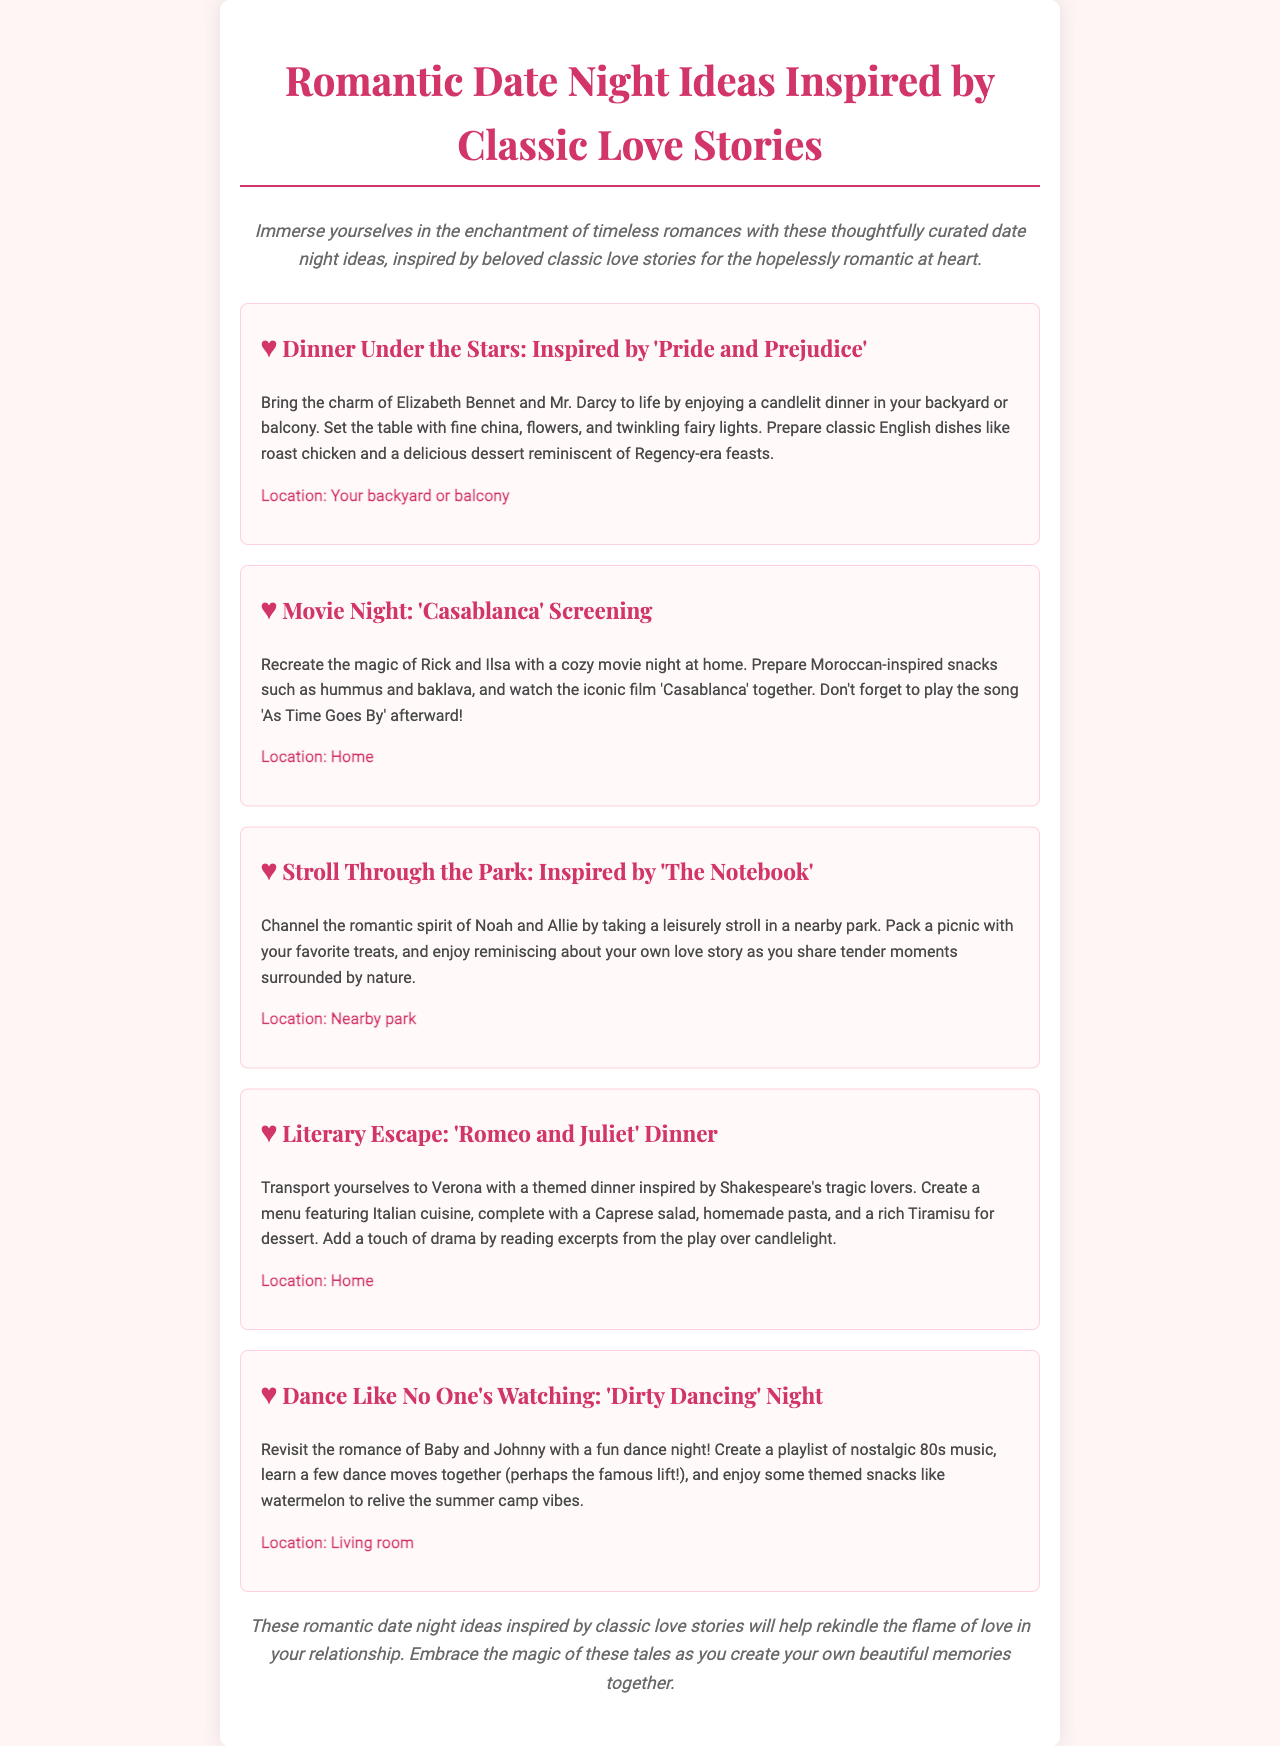what is the title of the newsletter? The title is prominently displayed at the top of the document, stating the theme of the ideas presented.
Answer: Romantic Date Night Ideas Inspired by Classic Love Stories how many date night ideas are presented in the document? The document lists a total of five different date night ideas for consideration.
Answer: Five which classic love story inspires the "Dinner Under the Stars" idea? This idea specifically references the charming relationship from a classic literary work that focuses on social class and romance.
Answer: Pride and Prejudice what location is suggested for the "Movie Night" date idea? The document clearly states where this cozy activity is intended to take place, keeping it intimate.
Answer: Home what type of cuisine is suggested for the "Romeo and Juliet" dinner? The themed dinner inspired by these tragic lovers features dishes that reflect the cultural background of the story.
Answer: Italian why is the "Dance Like No One's Watching" idea considered nostalgic? This date night idea connects to a film known for its iconic dance scenes, stirring memories of past eras and emotions.
Answer: 80s what is the overarching theme of the newsletter? The newsletter centers around a significant emotional connection and encourages readers to engage creatively with their partners through shared romantic experiences.
Answer: Classic love stories what is included in the "Literary Escape" date idea? This date idea combines a specific genre of literature with a themed culinary experience designed to evoke the style of the source material.
Answer: Dinner inspired by Shakespeare's "Romeo and Juliet" 